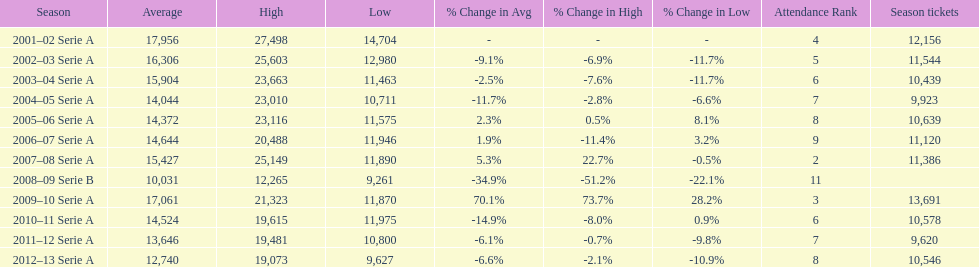How many seasons at the stadio ennio tardini had 11,000 or more season tickets? 5. 